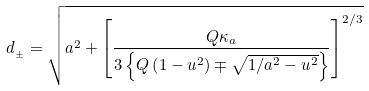<formula> <loc_0><loc_0><loc_500><loc_500>d _ { _ { \pm } } = \sqrt { a ^ { 2 } + \left [ \frac { Q \kappa _ { a } } { 3 \left \{ Q \left ( 1 - u ^ { 2 } \right ) \mp \sqrt { 1 / a ^ { 2 } - u ^ { 2 } } \right \} } \right ] ^ { 2 / 3 } }</formula> 